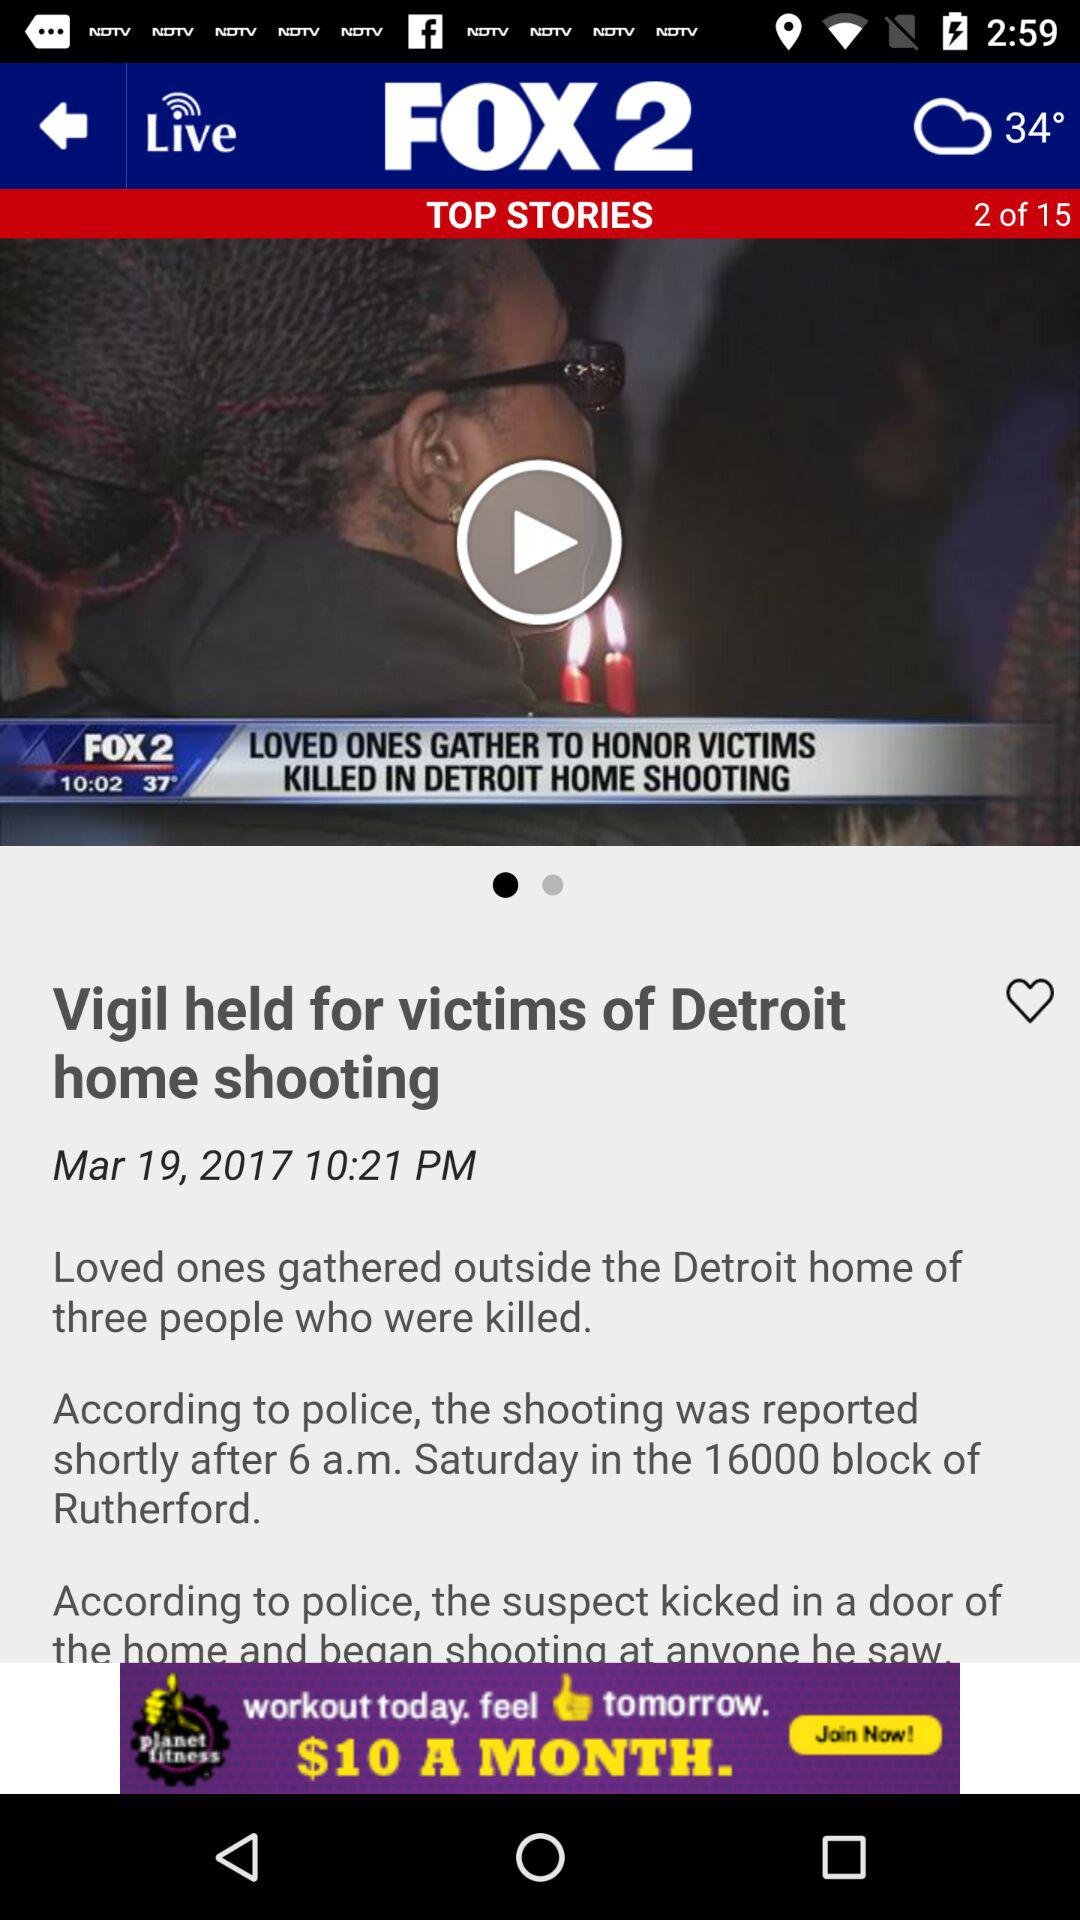What is the news story's headline? The headline is "Vigil held for victims of Detroit home shooting". 